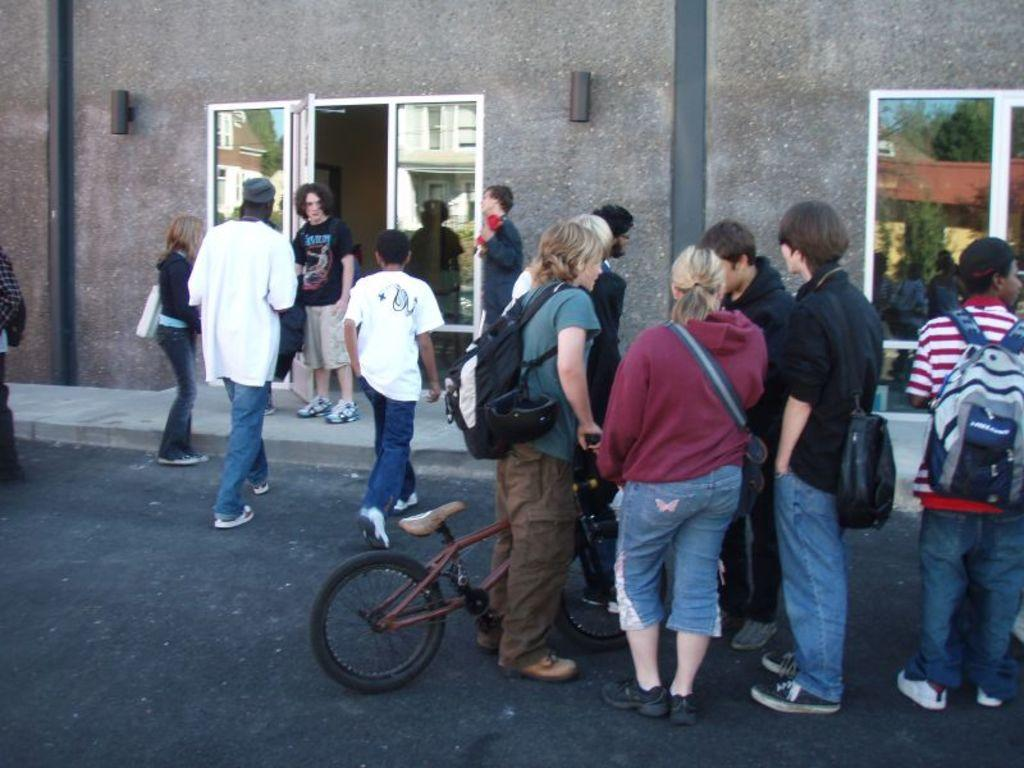What are the people in the image doing? The people in the image are standing on the road. What can be seen in the background of the image? There is a building with glass doors in the background of the image. What mode of transportation is being used by one of the people in the image? A person is riding a bicycle in the image. What is the person on the bicycle carrying? The person on the bicycle is wearing a bag. What type of screw can be seen holding the bicycle together in the image? There are no screws visible in the image, and the bicycle is not being held together by any visible screws. 